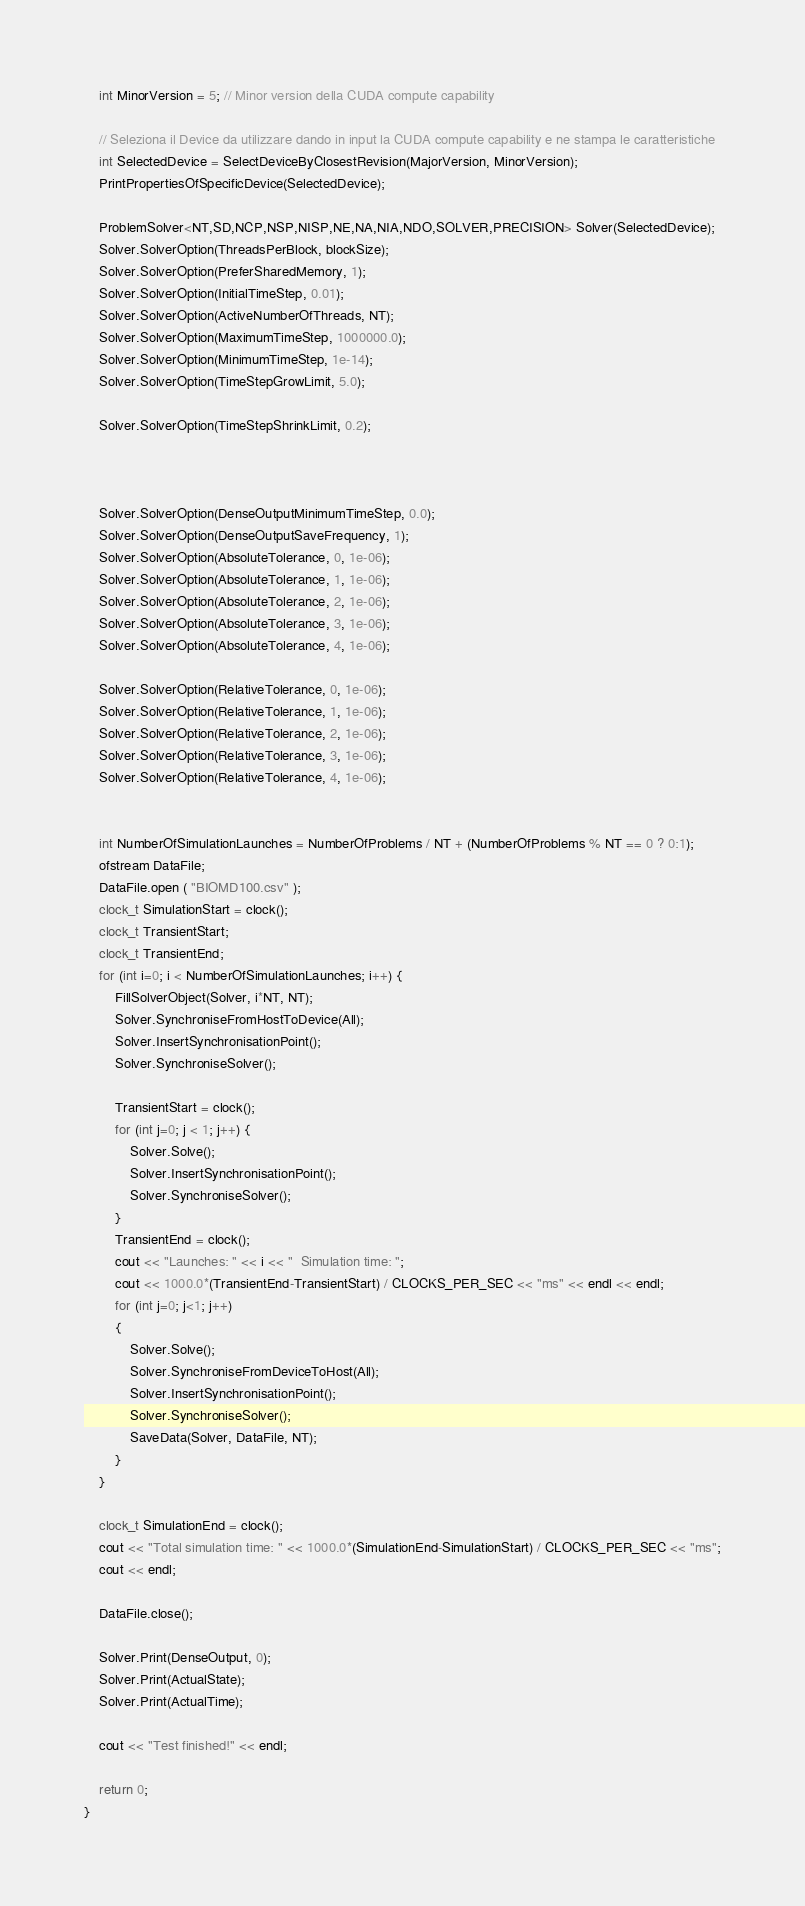<code> <loc_0><loc_0><loc_500><loc_500><_Cuda_>    int MinorVersion = 5; // Minor version della CUDA compute capability

    // Seleziona il Device da utilizzare dando in input la CUDA compute capability e ne stampa le caratteristiche
    int SelectedDevice = SelectDeviceByClosestRevision(MajorVersion, MinorVersion);
    PrintPropertiesOfSpecificDevice(SelectedDevice);

    ProblemSolver<NT,SD,NCP,NSP,NISP,NE,NA,NIA,NDO,SOLVER,PRECISION> Solver(SelectedDevice);
    Solver.SolverOption(ThreadsPerBlock, blockSize);
    Solver.SolverOption(PreferSharedMemory, 1);
    Solver.SolverOption(InitialTimeStep, 0.01);
    Solver.SolverOption(ActiveNumberOfThreads, NT);
    Solver.SolverOption(MaximumTimeStep, 1000000.0);
    Solver.SolverOption(MinimumTimeStep, 1e-14);
    Solver.SolverOption(TimeStepGrowLimit, 5.0);

    Solver.SolverOption(TimeStepShrinkLimit, 0.2);



    Solver.SolverOption(DenseOutputMinimumTimeStep, 0.0);
    Solver.SolverOption(DenseOutputSaveFrequency, 1);
    Solver.SolverOption(AbsoluteTolerance, 0, 1e-06);
    Solver.SolverOption(AbsoluteTolerance, 1, 1e-06);
    Solver.SolverOption(AbsoluteTolerance, 2, 1e-06);
    Solver.SolverOption(AbsoluteTolerance, 3, 1e-06);
    Solver.SolverOption(AbsoluteTolerance, 4, 1e-06);

    Solver.SolverOption(RelativeTolerance, 0, 1e-06);
    Solver.SolverOption(RelativeTolerance, 1, 1e-06);
    Solver.SolverOption(RelativeTolerance, 2, 1e-06);
    Solver.SolverOption(RelativeTolerance, 3, 1e-06);
    Solver.SolverOption(RelativeTolerance, 4, 1e-06);
   
    
    int NumberOfSimulationLaunches = NumberOfProblems / NT + (NumberOfProblems % NT == 0 ? 0:1);
    ofstream DataFile;
    DataFile.open ( "BIOMD100.csv" );
    clock_t SimulationStart = clock();
    clock_t TransientStart;
    clock_t TransientEnd;    
    for (int i=0; i < NumberOfSimulationLaunches; i++) {
        FillSolverObject(Solver, i*NT, NT);
        Solver.SynchroniseFromHostToDevice(All);
        Solver.InsertSynchronisationPoint();
        Solver.SynchroniseSolver();

        TransientStart = clock();
        for (int j=0; j < 1; j++) {
            Solver.Solve();
            Solver.InsertSynchronisationPoint();
            Solver.SynchroniseSolver();
        }
        TransientEnd = clock();
        cout << "Launches: " << i << "  Simulation time: ";
        cout << 1000.0*(TransientEnd-TransientStart) / CLOCKS_PER_SEC << "ms" << endl << endl;
        for (int j=0; j<1; j++)
        {
            Solver.Solve();
            Solver.SynchroniseFromDeviceToHost(All);
            Solver.InsertSynchronisationPoint();
            Solver.SynchroniseSolver();
            SaveData(Solver, DataFile, NT);
        }
    }

    clock_t SimulationEnd = clock();
    cout << "Total simulation time: " << 1000.0*(SimulationEnd-SimulationStart) / CLOCKS_PER_SEC << "ms";
    cout << endl;
	
    DataFile.close();
    
    Solver.Print(DenseOutput, 0);
    Solver.Print(ActualState);
    Solver.Print(ActualTime);
	
    cout << "Test finished!" << endl;

    return 0;
}

</code> 